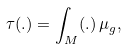<formula> <loc_0><loc_0><loc_500><loc_500>\tau ( . ) = \int _ { M } ( . ) \, \mu _ { g } ,</formula> 